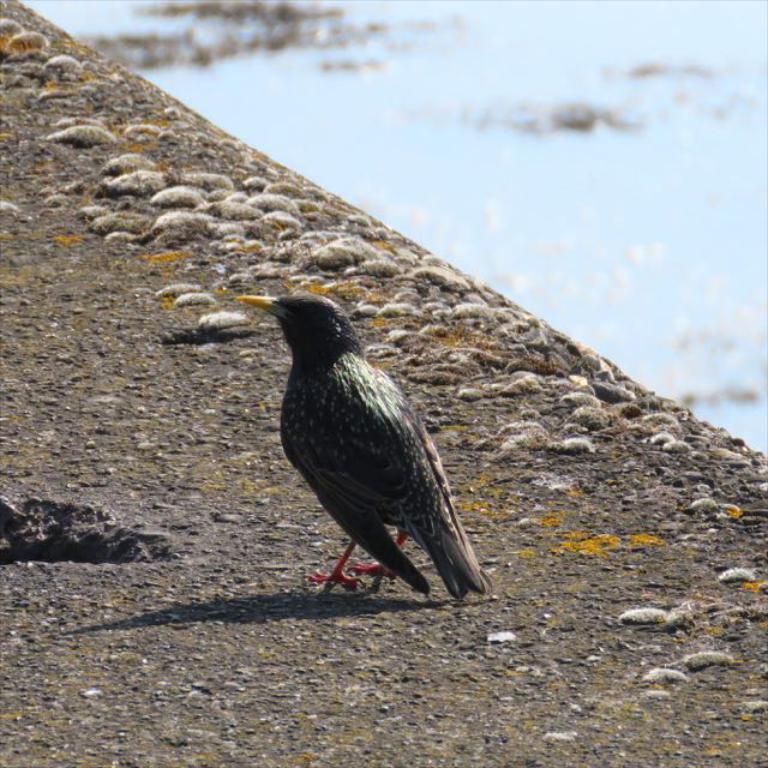Please provide a concise description of this image. In this image we can see a bird on the ground, on the ground we can see some objects which looks like the stones and also we can see some water. 